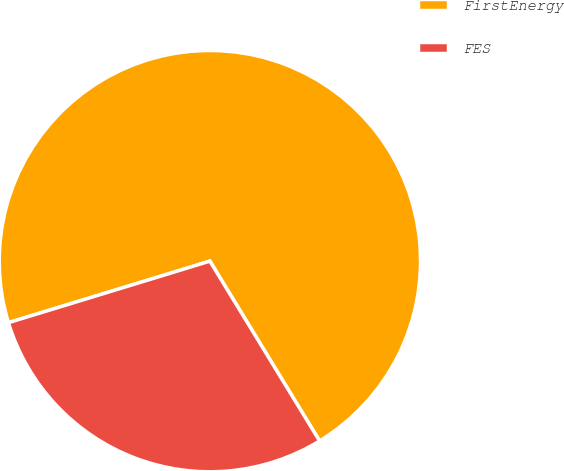<chart> <loc_0><loc_0><loc_500><loc_500><pie_chart><fcel>FirstEnergy<fcel>FES<nl><fcel>71.0%<fcel>29.0%<nl></chart> 